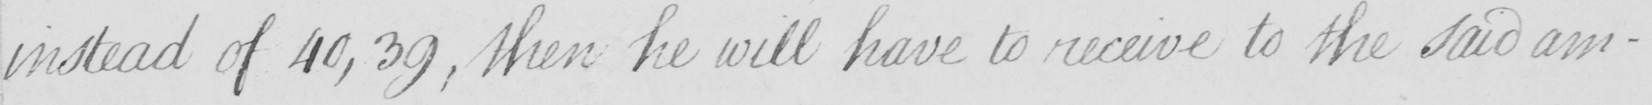Please provide the text content of this handwritten line. instead of 40 , 39 , then he will have to receive to the said am- 